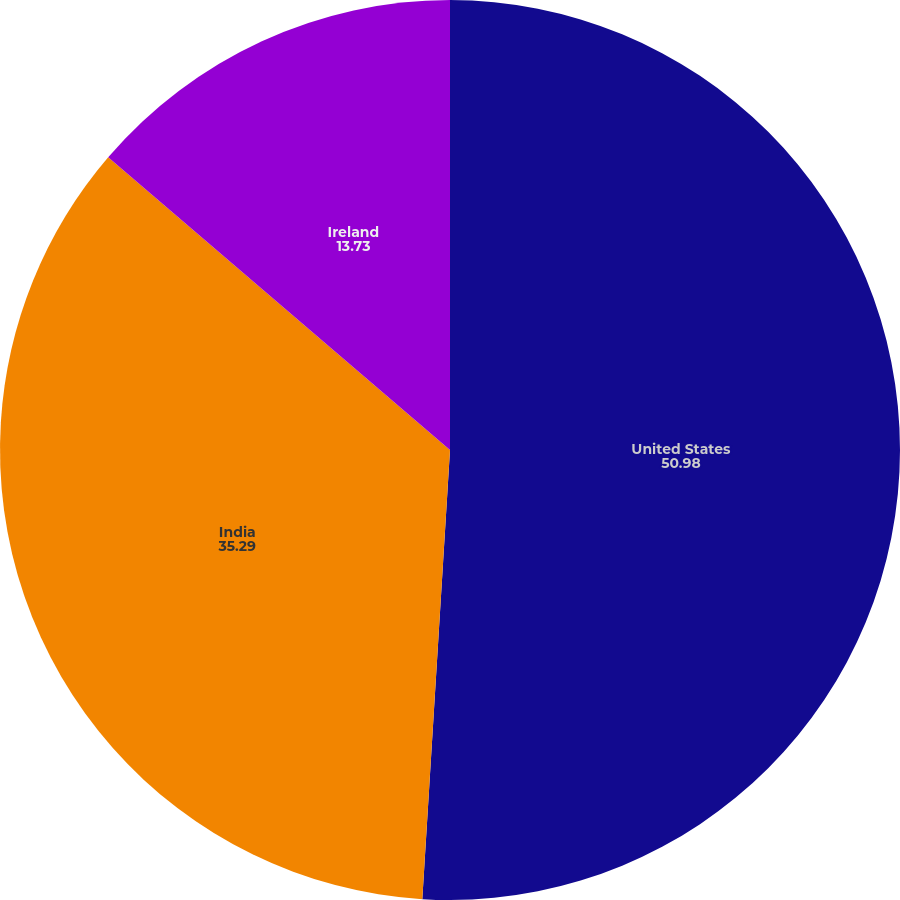Convert chart. <chart><loc_0><loc_0><loc_500><loc_500><pie_chart><fcel>United States<fcel>India<fcel>Ireland<nl><fcel>50.98%<fcel>35.29%<fcel>13.73%<nl></chart> 